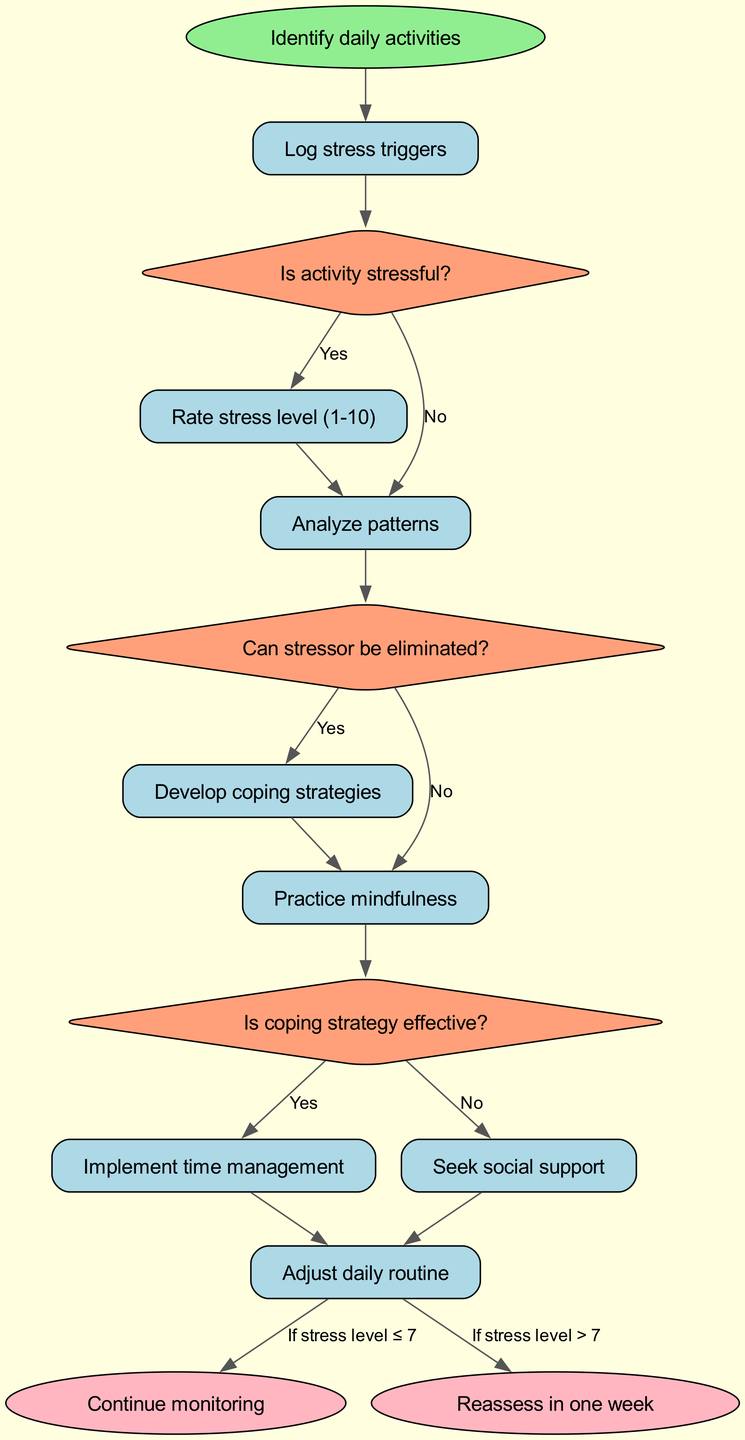What is the start node in the flowchart? The start node is labeled "Identify daily activities" as indicated in the diagram.
Answer: Identify daily activities What type of shape represents the end nodes? The end nodes are represented by ovals, as per the standard convention for flowchart end nodes, which are typically shaped that way.
Answer: Oval How many processes are there in total? There are eight processes listed in the flowchart: Log stress triggers, Rate stress level (1-10), Analyze patterns, Develop coping strategies, Practice mindfulness, Implement time management, Seek social support, and Adjust daily routine.
Answer: Eight What follows the decision about whether the stress level is greater than seven? If the stress level is greater than seven, it leads to the process "Seek social support," indicating a need for external help in managing stress.
Answer: Seek social support What is the outcome if the coping strategy is effective? If the coping strategy is effective, the flowchart directs to the end node labeled "Continue monitoring," indicating that one should persist in this method of management.
Answer: Continue monitoring Which process is reached after logging stress triggers? After logging stress triggers, the next process is to "Rate stress level (1-10)," as outlined in the diagram.
Answer: Rate stress level (1-10) What decision comes after analyzing patterns? The decision that follows analyzing patterns is "Is coping strategy effective?" This flow leads to evaluating the effectiveness of the strategies developed.
Answer: Is coping strategy effective? What do you do if the stressor can be eliminated? If the stressor can be eliminated, the flowchart indicates that one should "Adjust daily routine," suggesting taking actionable steps to reduce stress.
Answer: Adjust daily routine What is the process to undertake if the stress level is less than or equal to seven after monitoring? If the stress level is less than or equal to seven, the flowchart shows to "Reassess in one week," suggesting periodic evaluation of stress management progress.
Answer: Reassess in one week 